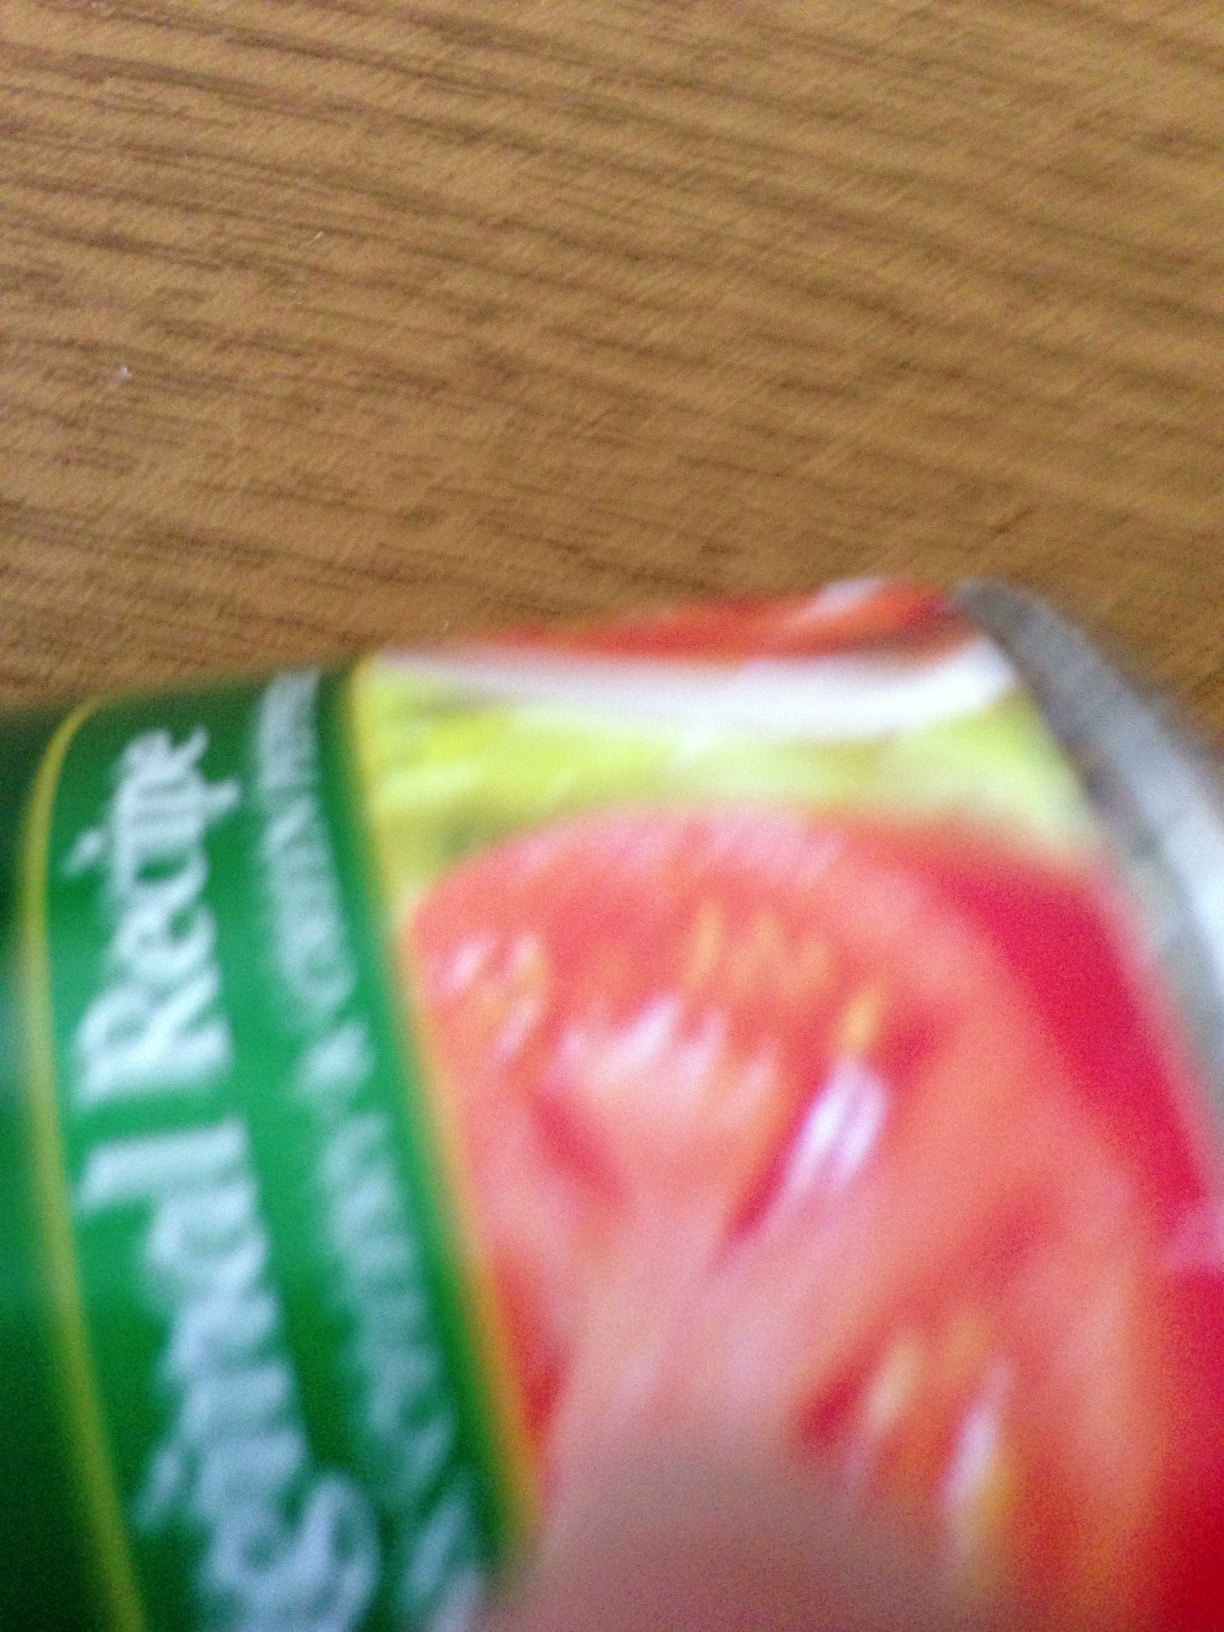I wonder if you could provide me with the expiration date on this product. Due to the blurriness of the image, I'm unable to clearly see the expiration date or any detailed text on the product label. Generally, expiration dates are found either at the top, bottom, or side of packaging. For a quicker answer, I would recommend checking these areas or using a clearer image if possible. 